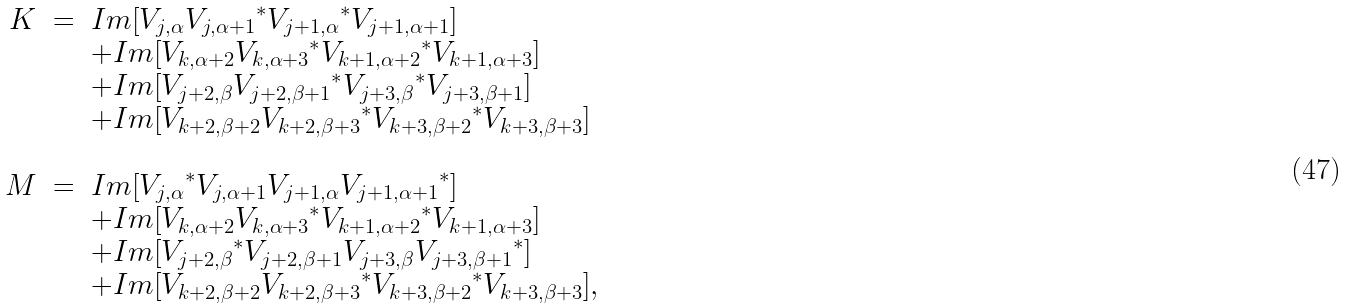<formula> <loc_0><loc_0><loc_500><loc_500>\begin{array} { r c l } K & = & I m [ V _ { j , \alpha } { V _ { j , \alpha + 1 } } ^ { * } { V _ { j + 1 , \alpha } } ^ { * } V _ { j + 1 , \alpha + 1 } ] \\ & & + I m [ V _ { k , \alpha + 2 } { V _ { k , \alpha + 3 } } ^ { * } { V _ { k + 1 , \alpha + 2 } } ^ { * } V _ { k + 1 , \alpha + 3 } ] \\ & & + I m [ V _ { j + 2 , \beta } { V _ { j + 2 , \beta + 1 } } ^ { * } { V _ { j + 3 , \beta } } ^ { * } V _ { j + 3 , \beta + 1 } ] \\ & & + I m [ V _ { k + 2 , \beta + 2 } { V _ { k + 2 , \beta + 3 } } ^ { * } { V _ { k + 3 , \beta + 2 } } ^ { * } V _ { k + 3 , \beta + 3 } ] \\ & & \\ M & = & I m [ { V _ { j , \alpha } } ^ { * } V _ { j , \alpha + 1 } V _ { j + 1 , \alpha } { V _ { j + 1 , \alpha + 1 } } ^ { * } ] \\ & & + I m [ V _ { k , \alpha + 2 } { V _ { k , \alpha + 3 } } ^ { * } { V _ { k + 1 , \alpha + 2 } } ^ { * } V _ { k + 1 , \alpha + 3 } ] \\ & & + I m [ { V _ { j + 2 , \beta } } ^ { * } V _ { j + 2 , \beta + 1 } V _ { j + 3 , \beta } { V _ { j + 3 , \beta + 1 } } ^ { * } ] \\ & & + I m [ V _ { k + 2 , \beta + 2 } { V _ { k + 2 , \beta + 3 } } ^ { * } { V _ { k + 3 , \beta + 2 } } ^ { * } V _ { k + 3 , \beta + 3 } ] , \\ & & \end{array}</formula> 